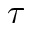Convert formula to latex. <formula><loc_0><loc_0><loc_500><loc_500>\tau</formula> 